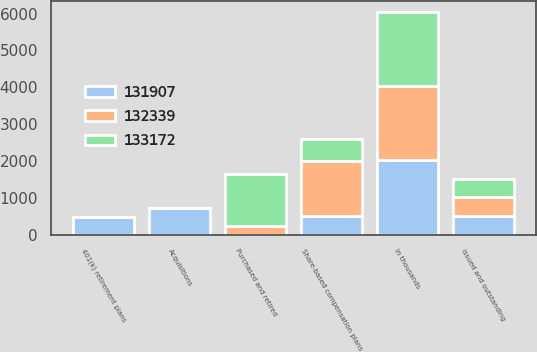Convert chart. <chart><loc_0><loc_0><loc_500><loc_500><stacked_bar_chart><ecel><fcel>in thousands<fcel>issued and outstanding<fcel>Acquisitions<fcel>401(k) retirement plans<fcel>Share-based compensation plans<fcel>Purchased and retired<nl><fcel>133172<fcel>2016<fcel>507<fcel>0<fcel>0<fcel>594<fcel>1427<nl><fcel>132339<fcel>2015<fcel>507<fcel>0<fcel>0<fcel>1493<fcel>228<nl><fcel>131907<fcel>2014<fcel>507<fcel>715<fcel>485<fcel>507<fcel>0<nl></chart> 